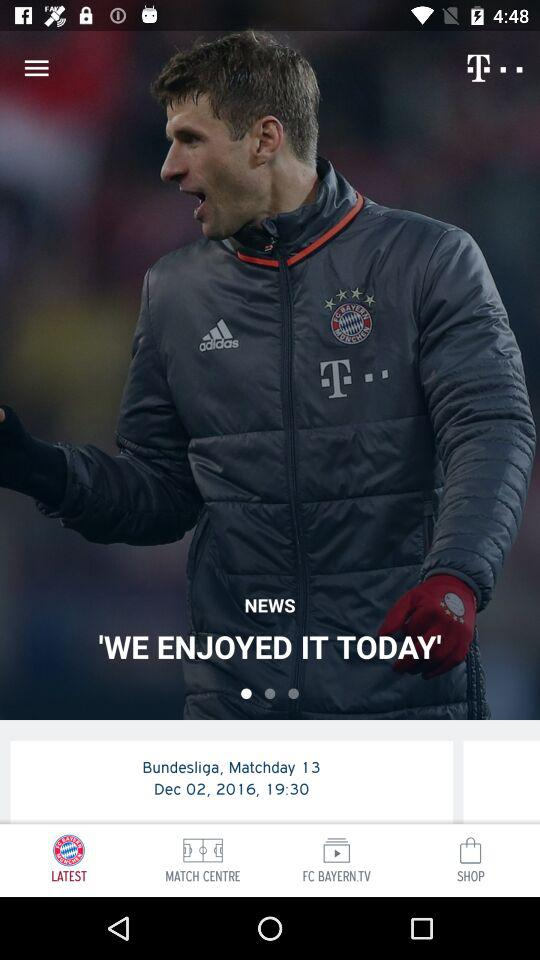What is the location of the match?
When the provided information is insufficient, respond with <no answer>. <no answer> 